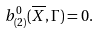Convert formula to latex. <formula><loc_0><loc_0><loc_500><loc_500>b ^ { 0 } _ { ( 2 ) } ( \overline { X } , \Gamma ) = 0 .</formula> 